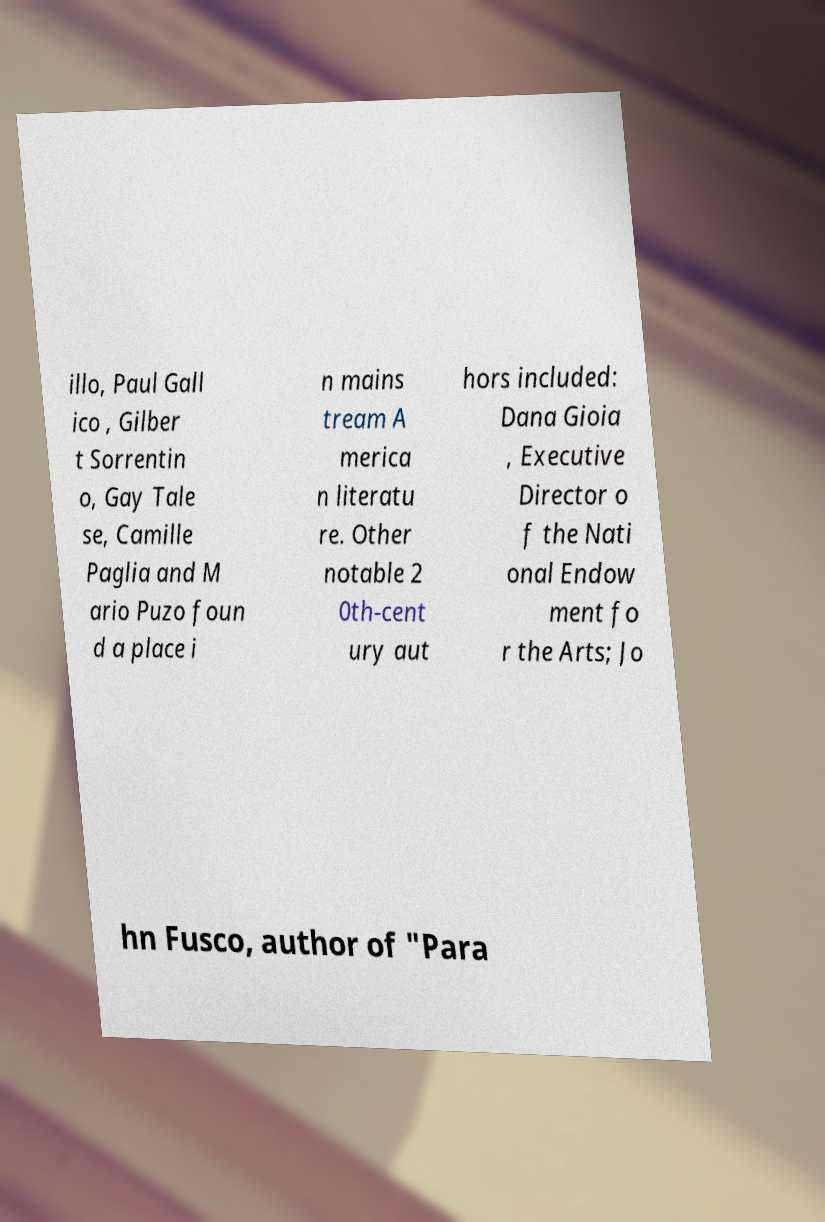There's text embedded in this image that I need extracted. Can you transcribe it verbatim? illo, Paul Gall ico , Gilber t Sorrentin o, Gay Tale se, Camille Paglia and M ario Puzo foun d a place i n mains tream A merica n literatu re. Other notable 2 0th-cent ury aut hors included: Dana Gioia , Executive Director o f the Nati onal Endow ment fo r the Arts; Jo hn Fusco, author of "Para 